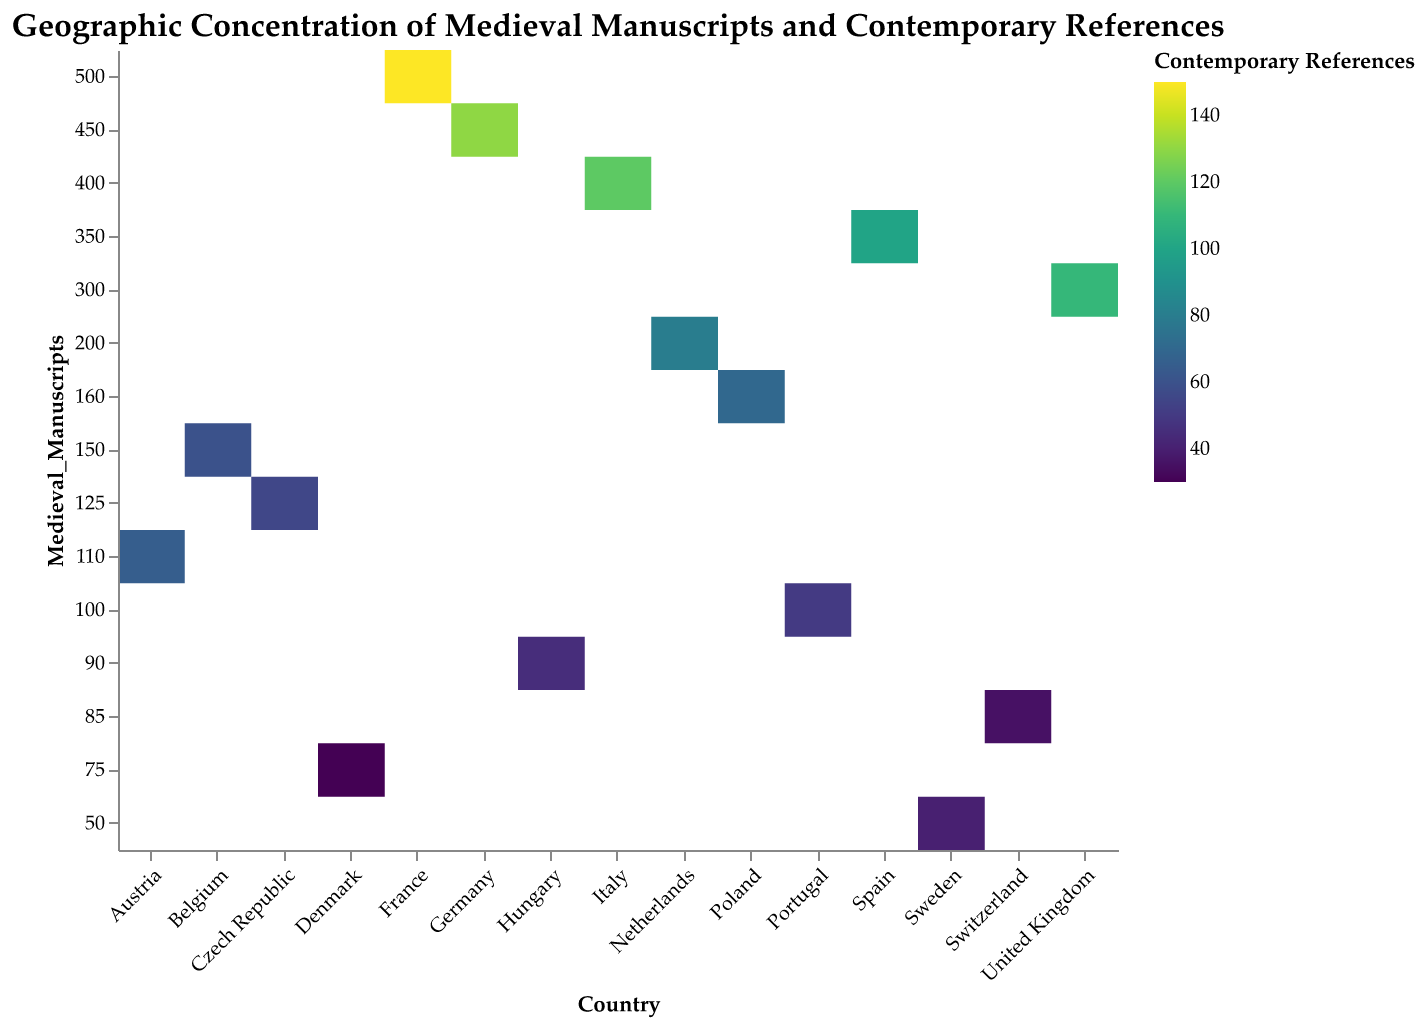How many countries are represented in the heatmap? There are individual data points corresponding to each country. By counting the unique entries in the "Country" column, we get the total number. In the heatmap, it's straightforward to count these entries.
Answer: 15 Which country has the highest number of medieval manuscripts? By referring to the y-axis, which lists the number of medieval manuscripts, we see that the country with the highest number is at the top of the list. The corresponding country for the value 500 is France.
Answer: France What is the relationship between medieval manuscripts and contemporary references for Germany? Locate Germany on the x-axis, follow the corresponding rectangular cell upward to check its value from the y-axis for medieval manuscripts (450) and the color intensity for contemporary references. Germany shows 450 medieval manuscripts and 130 contemporary references.
Answer: 450 manuscripts, 130 references Which two countries have the closest number of medieval manuscripts? By observing the y-axis, it is apparent that Poland (160) and Belgium (150) have very close values for the number of medieval manuscripts.
Answer: Poland and Belgium On average, how many medieval manuscripts are there per country? Summing the values in the "Medieval_Manuscripts" column and dividing by the total number of countries gives the average. Calculate as follows: (500 + 450 + 400 + 300 + 350 + 200 + 150 + 100 + 50 + 75 + 125 + 90 + 160 + 85 + 110) / 15 = 304.67
Answer: 304.67 Which country has the lowest number of contemporary references, and how many are there? The heatmap colors reflect the number of contemporary references, with lighter colors indicating fewer references. Sweden, with a value of 40, is the lightest color in the map.
Answer: Sweden, 40 Compare the number of medieval manuscripts and contemporary references between Italy and the United Kingdom. For Italy: 400 medieval manuscripts and 120 contemporary references. For the United Kingdom: 300 medieval manuscripts and 110 contemporary references. Italy has more manuscripts (400 vs 300) and references (120 vs 110).
Answer: Italy has more Which country has the highest ratio of contemporary references to medieval manuscripts? To find this, divide the contemporary references by the medieval manuscripts for each country, then compare. Without exact data for all calculations here, it's evident from color intensity and lower manuscript numbers that Denmark (30/75 = 0.4) and Sweden (40/50 = 0.8) have high ratios. Sweden has the highest ratio of 0.8.
Answer: Sweden Is there a general trend between the number of medieval manuscripts and contemporary references among these countries? Generally, darker colors (more references) are associated with higher numbers of medieval manuscripts, indicating a positive correlation. France, Germany, and Italy, with high manuscript numbers, have more contemporary references.
Answer: Positive correlation For which country do contemporary references most closely match the number of medieval manuscripts? Contemporary references are consistently lower, but countries like Belgium (60 references to 150 manuscripts) have a closer reference-to-manuscript ratio. Calculate Belgium's ratio 60/150 = 0.4, closely matching other similar ratios.
Answer: Belgium 